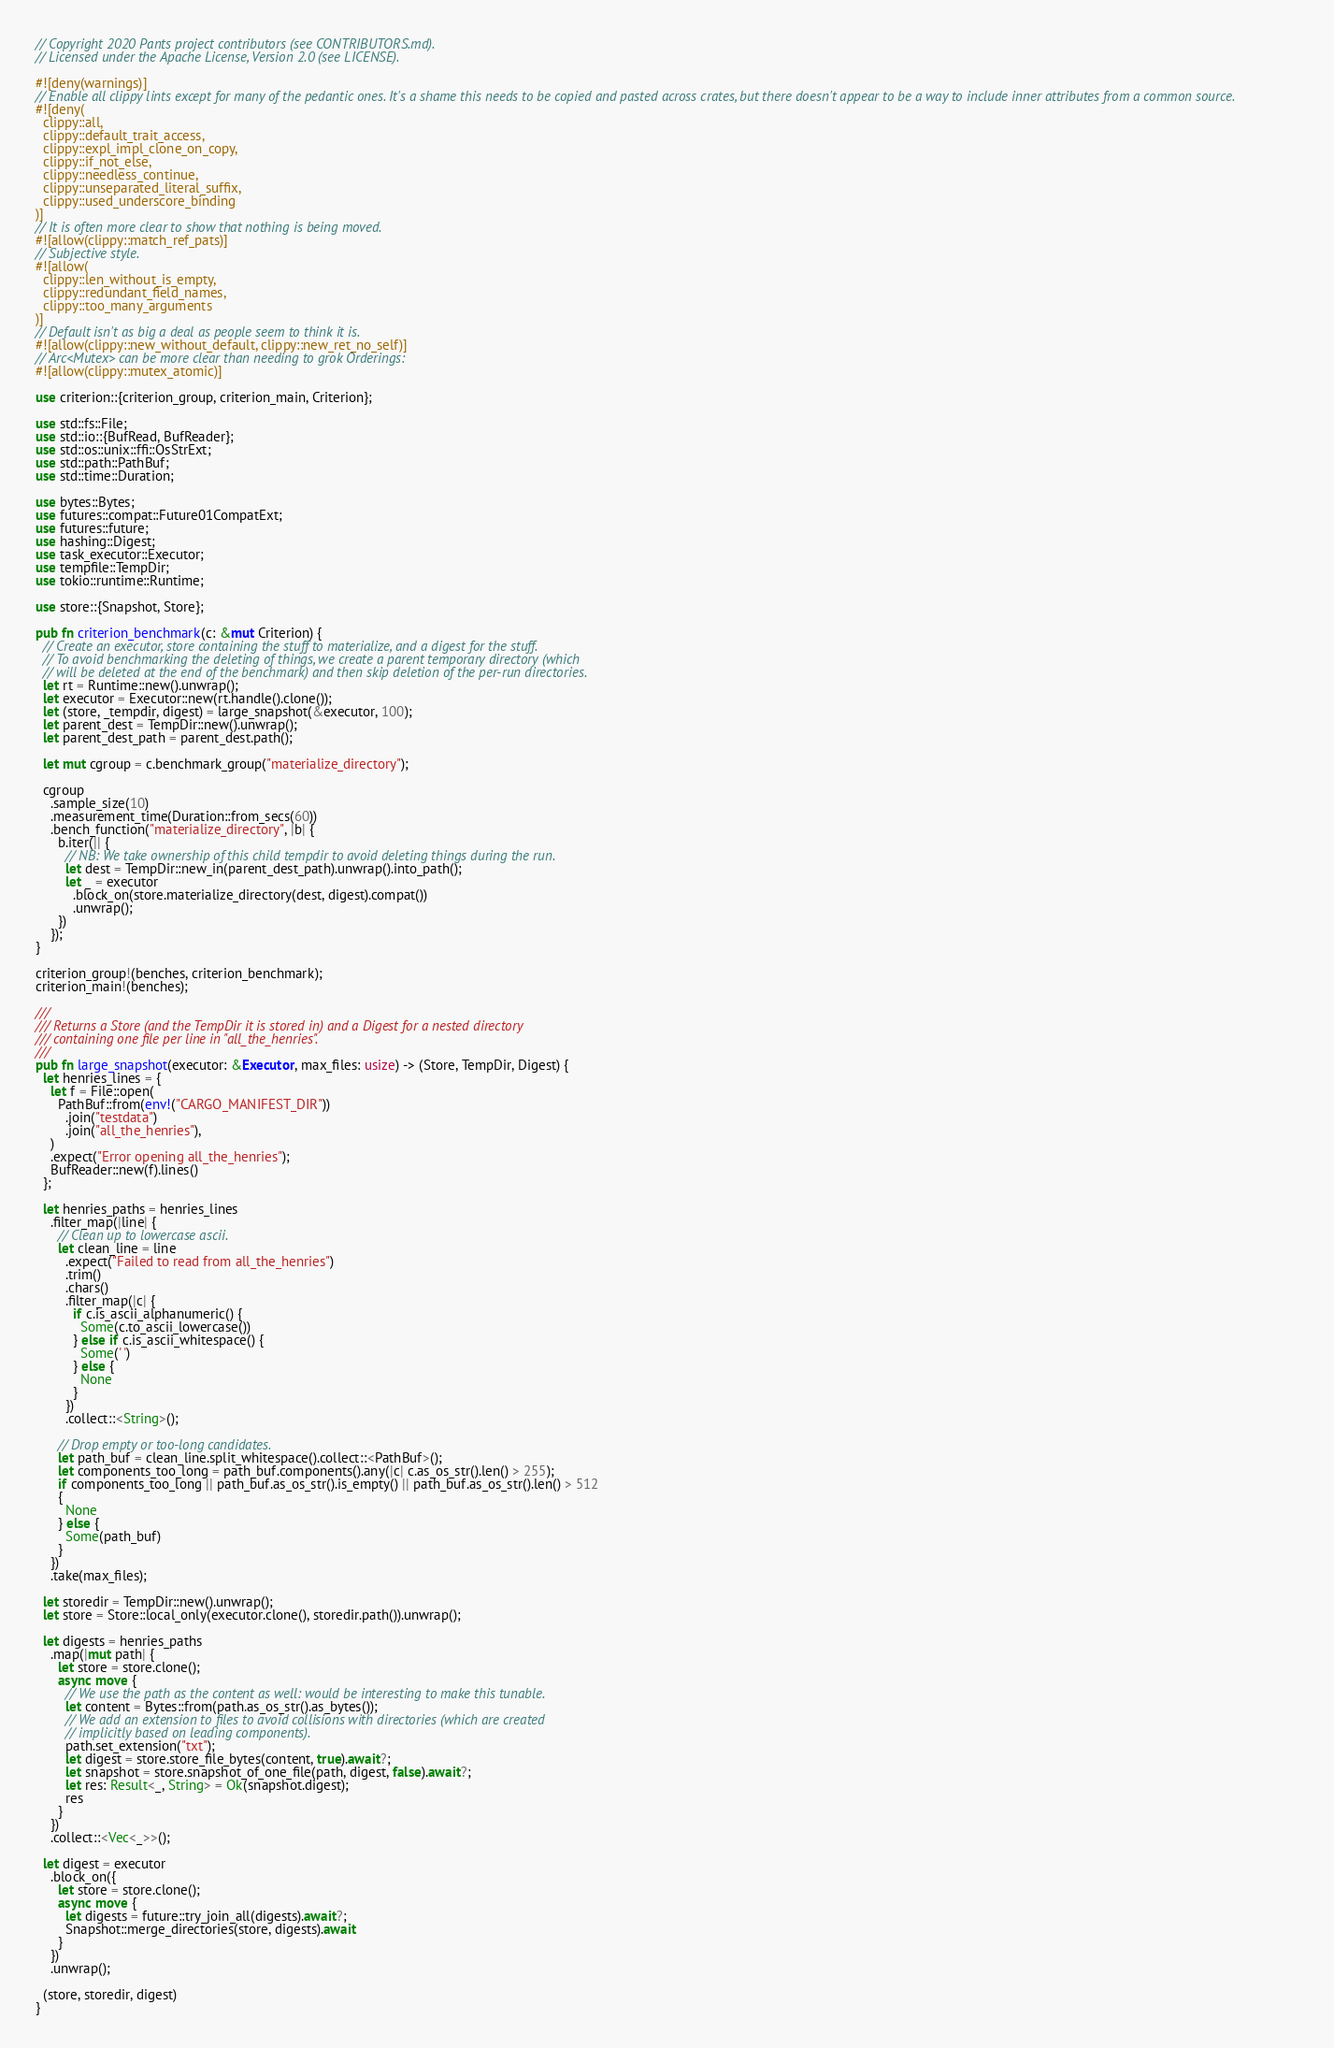Convert code to text. <code><loc_0><loc_0><loc_500><loc_500><_Rust_>// Copyright 2020 Pants project contributors (see CONTRIBUTORS.md).
// Licensed under the Apache License, Version 2.0 (see LICENSE).

#![deny(warnings)]
// Enable all clippy lints except for many of the pedantic ones. It's a shame this needs to be copied and pasted across crates, but there doesn't appear to be a way to include inner attributes from a common source.
#![deny(
  clippy::all,
  clippy::default_trait_access,
  clippy::expl_impl_clone_on_copy,
  clippy::if_not_else,
  clippy::needless_continue,
  clippy::unseparated_literal_suffix,
  clippy::used_underscore_binding
)]
// It is often more clear to show that nothing is being moved.
#![allow(clippy::match_ref_pats)]
// Subjective style.
#![allow(
  clippy::len_without_is_empty,
  clippy::redundant_field_names,
  clippy::too_many_arguments
)]
// Default isn't as big a deal as people seem to think it is.
#![allow(clippy::new_without_default, clippy::new_ret_no_self)]
// Arc<Mutex> can be more clear than needing to grok Orderings:
#![allow(clippy::mutex_atomic)]

use criterion::{criterion_group, criterion_main, Criterion};

use std::fs::File;
use std::io::{BufRead, BufReader};
use std::os::unix::ffi::OsStrExt;
use std::path::PathBuf;
use std::time::Duration;

use bytes::Bytes;
use futures::compat::Future01CompatExt;
use futures::future;
use hashing::Digest;
use task_executor::Executor;
use tempfile::TempDir;
use tokio::runtime::Runtime;

use store::{Snapshot, Store};

pub fn criterion_benchmark(c: &mut Criterion) {
  // Create an executor, store containing the stuff to materialize, and a digest for the stuff.
  // To avoid benchmarking the deleting of things, we create a parent temporary directory (which
  // will be deleted at the end of the benchmark) and then skip deletion of the per-run directories.
  let rt = Runtime::new().unwrap();
  let executor = Executor::new(rt.handle().clone());
  let (store, _tempdir, digest) = large_snapshot(&executor, 100);
  let parent_dest = TempDir::new().unwrap();
  let parent_dest_path = parent_dest.path();

  let mut cgroup = c.benchmark_group("materialize_directory");

  cgroup
    .sample_size(10)
    .measurement_time(Duration::from_secs(60))
    .bench_function("materialize_directory", |b| {
      b.iter(|| {
        // NB: We take ownership of this child tempdir to avoid deleting things during the run.
        let dest = TempDir::new_in(parent_dest_path).unwrap().into_path();
        let _ = executor
          .block_on(store.materialize_directory(dest, digest).compat())
          .unwrap();
      })
    });
}

criterion_group!(benches, criterion_benchmark);
criterion_main!(benches);

///
/// Returns a Store (and the TempDir it is stored in) and a Digest for a nested directory
/// containing one file per line in "all_the_henries".
///
pub fn large_snapshot(executor: &Executor, max_files: usize) -> (Store, TempDir, Digest) {
  let henries_lines = {
    let f = File::open(
      PathBuf::from(env!("CARGO_MANIFEST_DIR"))
        .join("testdata")
        .join("all_the_henries"),
    )
    .expect("Error opening all_the_henries");
    BufReader::new(f).lines()
  };

  let henries_paths = henries_lines
    .filter_map(|line| {
      // Clean up to lowercase ascii.
      let clean_line = line
        .expect("Failed to read from all_the_henries")
        .trim()
        .chars()
        .filter_map(|c| {
          if c.is_ascii_alphanumeric() {
            Some(c.to_ascii_lowercase())
          } else if c.is_ascii_whitespace() {
            Some(' ')
          } else {
            None
          }
        })
        .collect::<String>();

      // Drop empty or too-long candidates.
      let path_buf = clean_line.split_whitespace().collect::<PathBuf>();
      let components_too_long = path_buf.components().any(|c| c.as_os_str().len() > 255);
      if components_too_long || path_buf.as_os_str().is_empty() || path_buf.as_os_str().len() > 512
      {
        None
      } else {
        Some(path_buf)
      }
    })
    .take(max_files);

  let storedir = TempDir::new().unwrap();
  let store = Store::local_only(executor.clone(), storedir.path()).unwrap();

  let digests = henries_paths
    .map(|mut path| {
      let store = store.clone();
      async move {
        // We use the path as the content as well: would be interesting to make this tunable.
        let content = Bytes::from(path.as_os_str().as_bytes());
        // We add an extension to files to avoid collisions with directories (which are created
        // implicitly based on leading components).
        path.set_extension("txt");
        let digest = store.store_file_bytes(content, true).await?;
        let snapshot = store.snapshot_of_one_file(path, digest, false).await?;
        let res: Result<_, String> = Ok(snapshot.digest);
        res
      }
    })
    .collect::<Vec<_>>();

  let digest = executor
    .block_on({
      let store = store.clone();
      async move {
        let digests = future::try_join_all(digests).await?;
        Snapshot::merge_directories(store, digests).await
      }
    })
    .unwrap();

  (store, storedir, digest)
}
</code> 